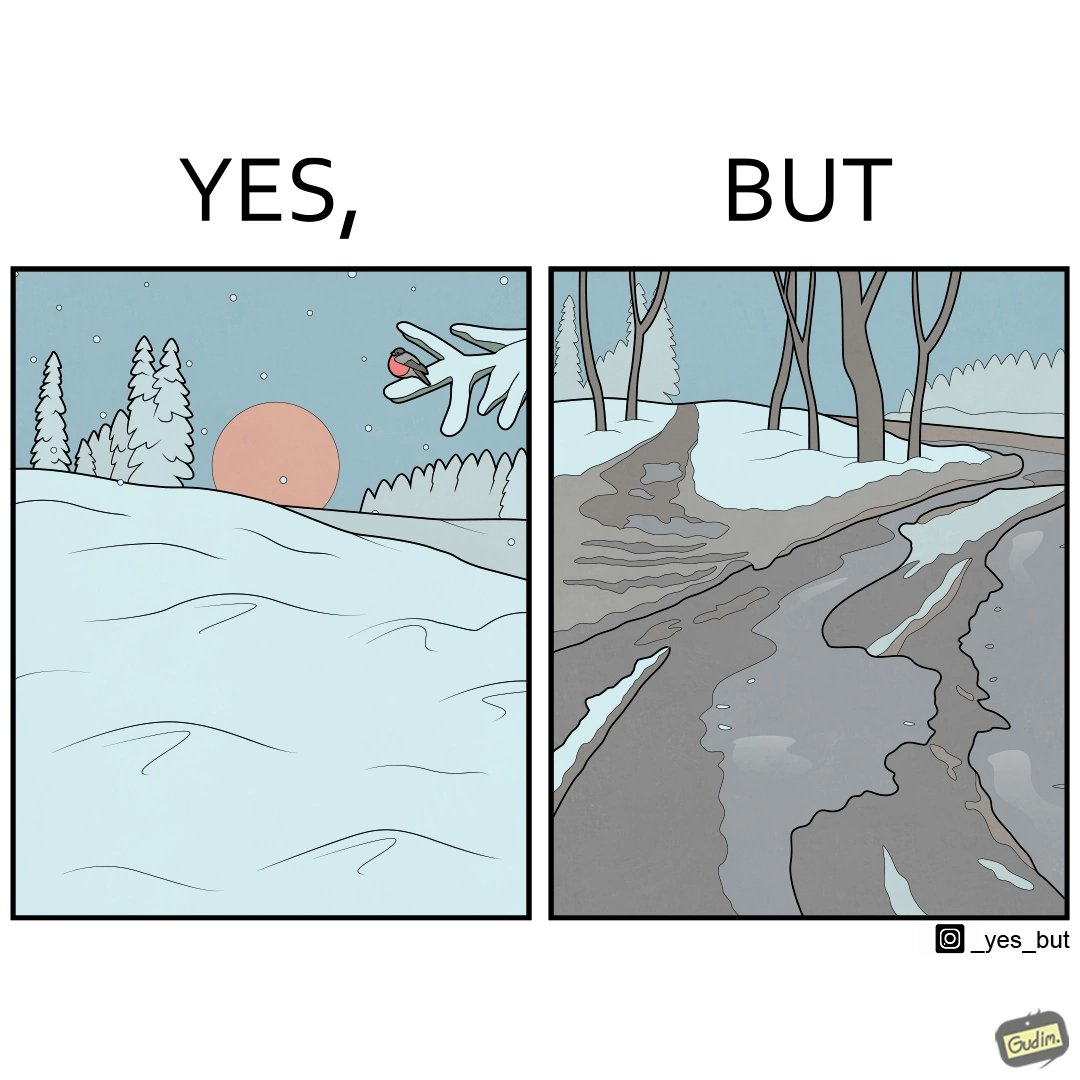Describe the satirical element in this image. The image is funny, as from far, snow covered mountains look really scenic and completely white, but when zooming in near trees, the ground is partially covered in snow, and is not as scenic anymore. 